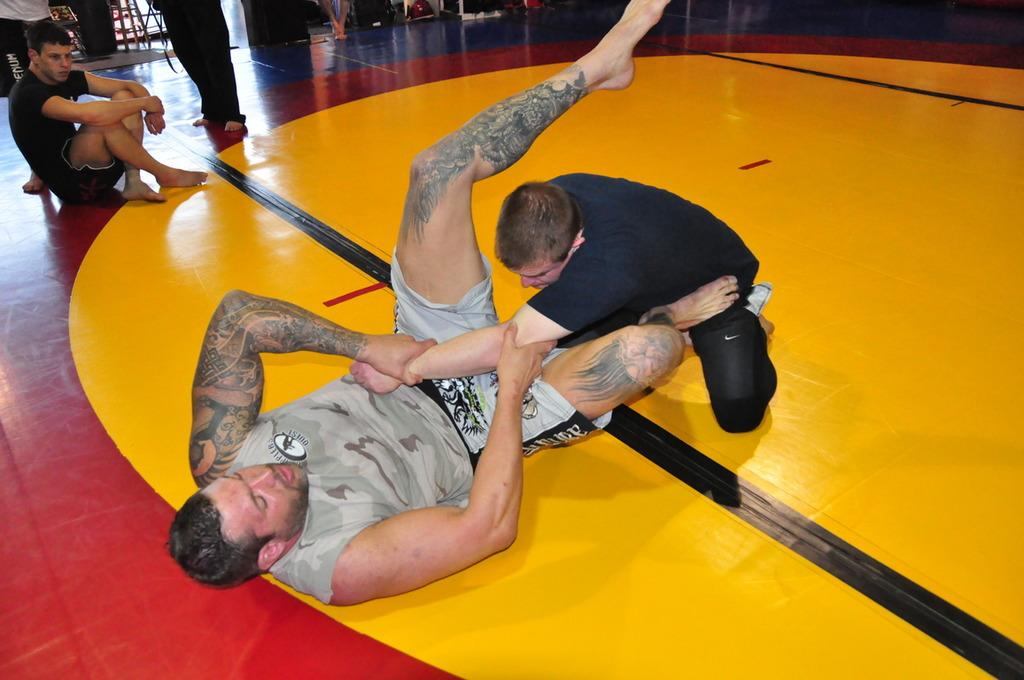Who or what can be seen in the image? There are people in the image. What is the surface beneath the people? There is a floor visible in the image. Can you describe any other objects or elements in the image? There are other objects in the image. What color is the kitten's stocking in the image? There is no kitten or stocking present in the image. 